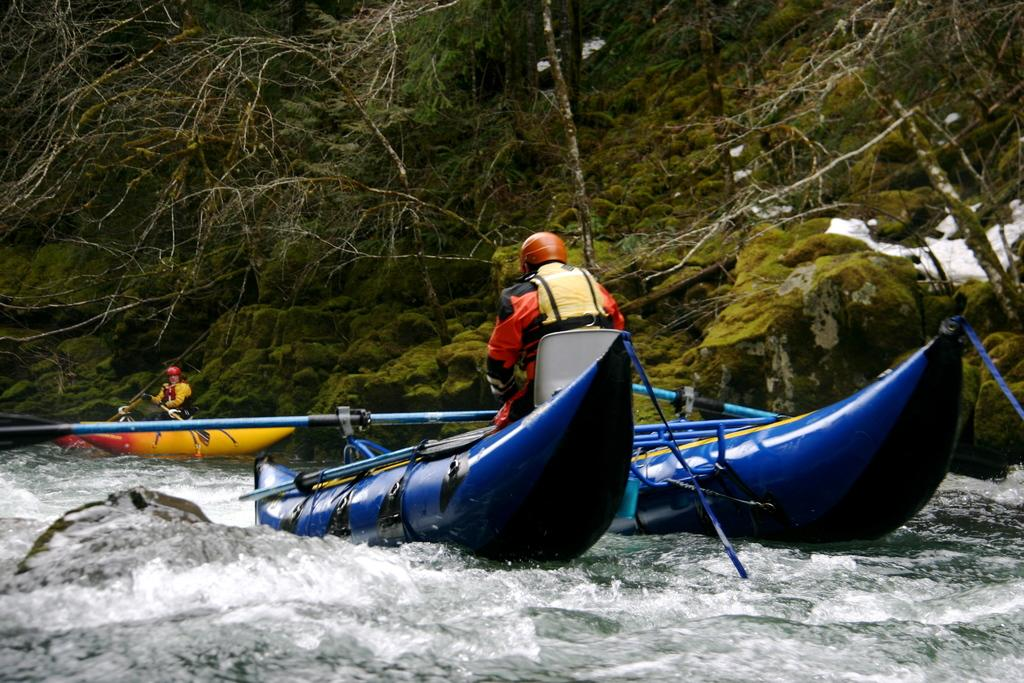What is happening on the water in the image? There are boats on the water in the image. Who is on the boats? There are two persons sitting on the boats. What are the persons using to move the boats? There are paddles in the image. What can be seen in the background of the image? There are trees and plants in the background of the image. What type of bun is being used to secure the boats in the image? There is no bun present in the image; the boats are on the water and not secured by any bun. How does the water's comfort level affect the boaters in the image? The image does not provide any information about the water's comfort level or its effect on the boaters. 